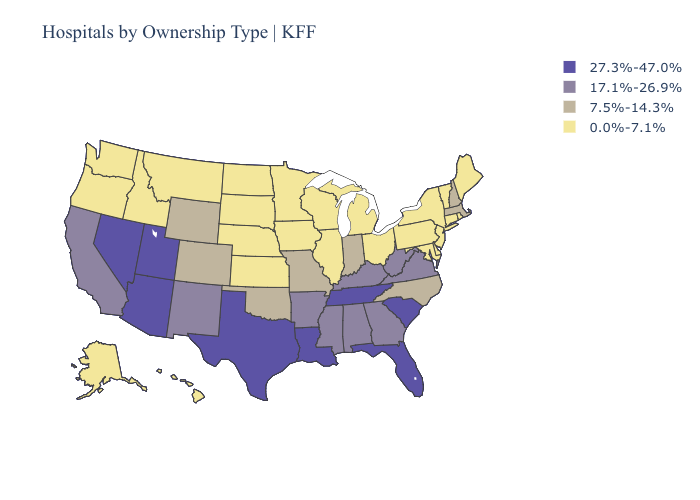Name the states that have a value in the range 17.1%-26.9%?
Be succinct. Alabama, Arkansas, California, Georgia, Kentucky, Mississippi, New Mexico, Virginia, West Virginia. What is the value of Michigan?
Quick response, please. 0.0%-7.1%. Name the states that have a value in the range 17.1%-26.9%?
Keep it brief. Alabama, Arkansas, California, Georgia, Kentucky, Mississippi, New Mexico, Virginia, West Virginia. What is the value of Montana?
Give a very brief answer. 0.0%-7.1%. Name the states that have a value in the range 0.0%-7.1%?
Keep it brief. Alaska, Connecticut, Delaware, Hawaii, Idaho, Illinois, Iowa, Kansas, Maine, Maryland, Michigan, Minnesota, Montana, Nebraska, New Jersey, New York, North Dakota, Ohio, Oregon, Pennsylvania, Rhode Island, South Dakota, Vermont, Washington, Wisconsin. What is the value of Utah?
Be succinct. 27.3%-47.0%. Name the states that have a value in the range 17.1%-26.9%?
Write a very short answer. Alabama, Arkansas, California, Georgia, Kentucky, Mississippi, New Mexico, Virginia, West Virginia. What is the lowest value in the Northeast?
Short answer required. 0.0%-7.1%. What is the highest value in states that border Idaho?
Give a very brief answer. 27.3%-47.0%. Does Massachusetts have the lowest value in the Northeast?
Concise answer only. No. Does Georgia have a lower value than Arizona?
Give a very brief answer. Yes. Does Wisconsin have the lowest value in the USA?
Quick response, please. Yes. Which states have the lowest value in the USA?
Keep it brief. Alaska, Connecticut, Delaware, Hawaii, Idaho, Illinois, Iowa, Kansas, Maine, Maryland, Michigan, Minnesota, Montana, Nebraska, New Jersey, New York, North Dakota, Ohio, Oregon, Pennsylvania, Rhode Island, South Dakota, Vermont, Washington, Wisconsin. Does Kentucky have the lowest value in the USA?
Write a very short answer. No. 